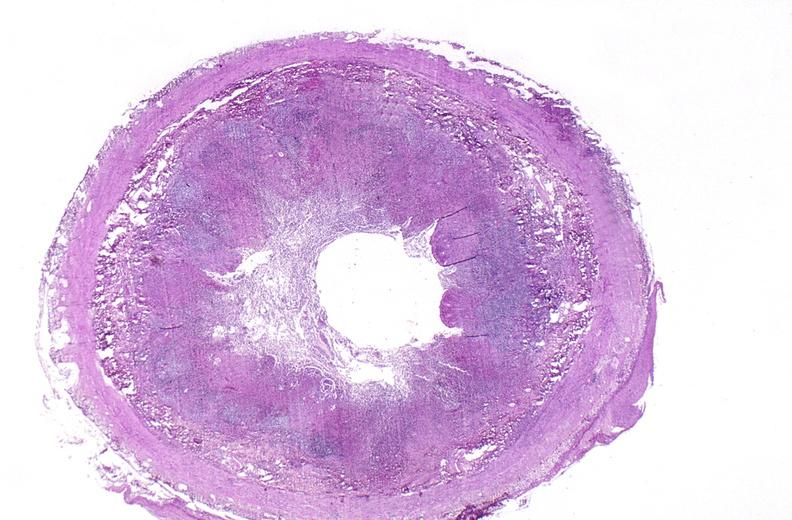s gastrointestinal present?
Answer the question using a single word or phrase. Yes 